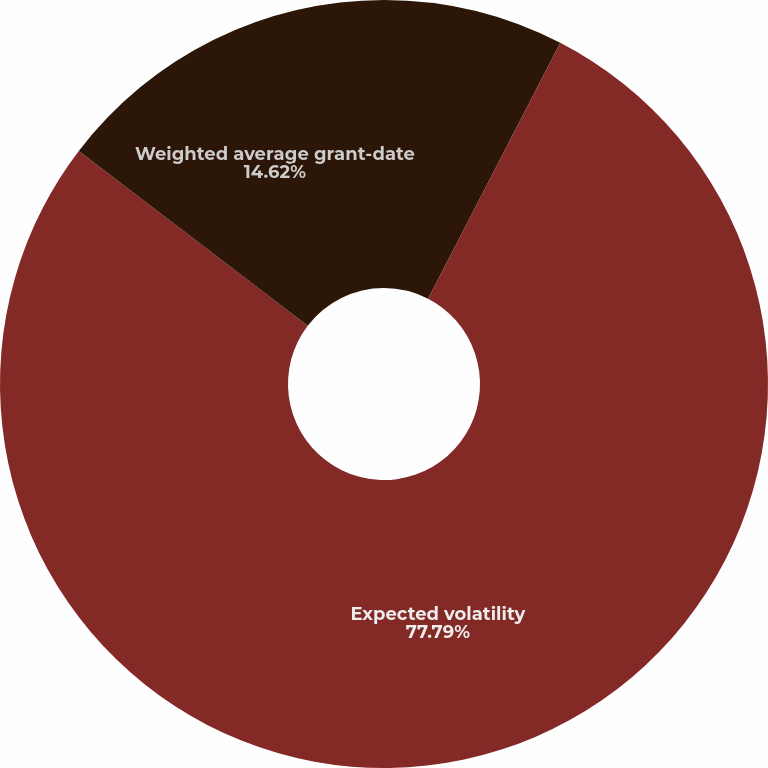<chart> <loc_0><loc_0><loc_500><loc_500><pie_chart><fcel>Expected term (in years)<fcel>Expected volatility<fcel>Weighted average grant-date<nl><fcel>7.59%<fcel>77.79%<fcel>14.62%<nl></chart> 